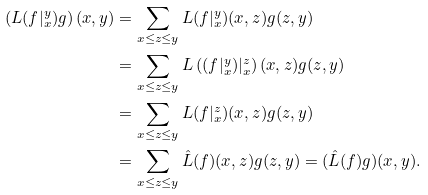Convert formula to latex. <formula><loc_0><loc_0><loc_500><loc_500>\left ( L ( f | _ { x } ^ { y } ) g \right ) ( x , y ) & = \sum _ { x \leq z \leq y } L ( f | _ { x } ^ { y } ) ( x , z ) g ( z , y ) \\ & = \sum _ { x \leq z \leq y } L \left ( ( f | _ { x } ^ { y } ) | _ { x } ^ { z } \right ) ( x , z ) g ( z , y ) \\ & = \sum _ { x \leq z \leq y } L ( f | _ { x } ^ { z } ) ( x , z ) g ( z , y ) \\ & = \sum _ { x \leq z \leq y } \hat { L } ( f ) ( x , z ) g ( z , y ) = ( \hat { L } ( f ) g ) ( x , y ) .</formula> 